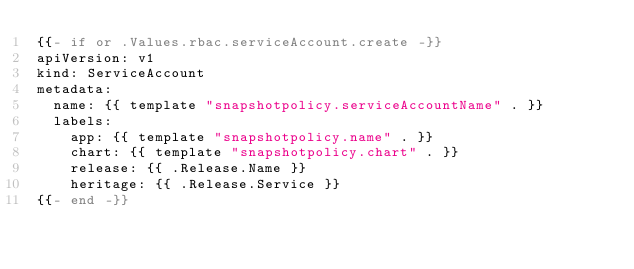<code> <loc_0><loc_0><loc_500><loc_500><_YAML_>{{- if or .Values.rbac.serviceAccount.create -}}
apiVersion: v1
kind: ServiceAccount
metadata:
  name: {{ template "snapshotpolicy.serviceAccountName" . }}
  labels:
    app: {{ template "snapshotpolicy.name" . }}
    chart: {{ template "snapshotpolicy.chart" . }}
    release: {{ .Release.Name }}
    heritage: {{ .Release.Service }}
{{- end -}}</code> 